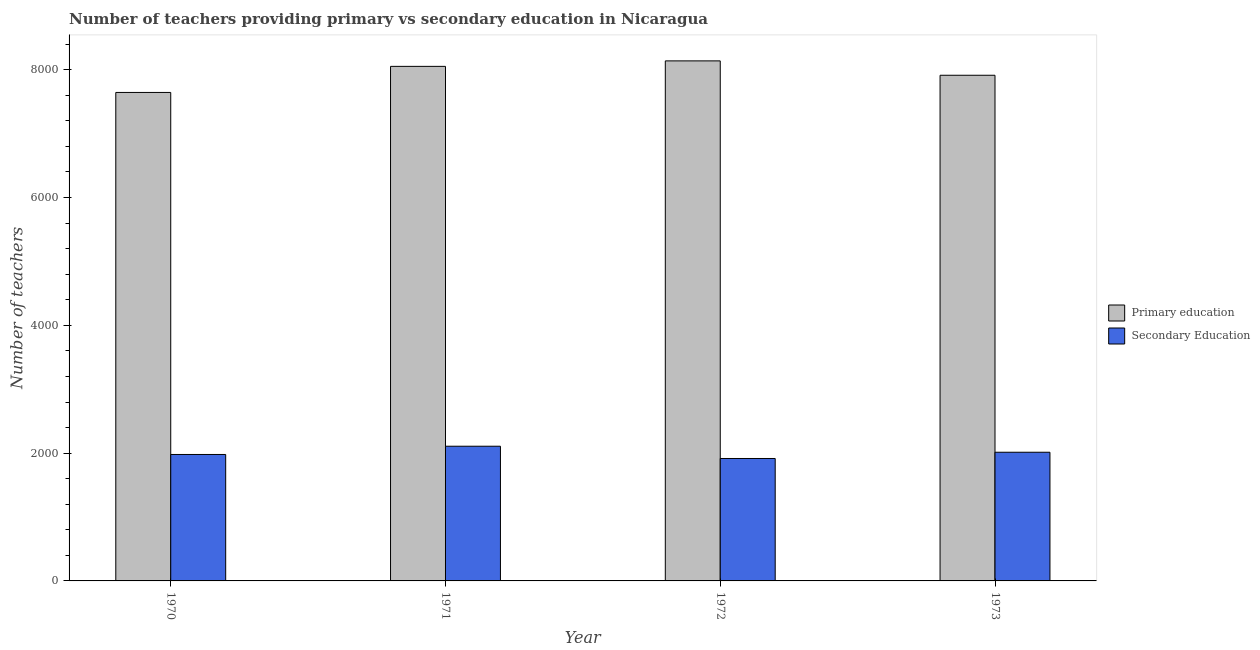How many different coloured bars are there?
Your answer should be compact. 2. How many bars are there on the 2nd tick from the left?
Offer a terse response. 2. In how many cases, is the number of bars for a given year not equal to the number of legend labels?
Offer a very short reply. 0. What is the number of primary teachers in 1972?
Offer a terse response. 8139. Across all years, what is the maximum number of primary teachers?
Ensure brevity in your answer.  8139. Across all years, what is the minimum number of primary teachers?
Provide a succinct answer. 7645. In which year was the number of primary teachers minimum?
Provide a succinct answer. 1970. What is the total number of primary teachers in the graph?
Keep it short and to the point. 3.18e+04. What is the difference between the number of primary teachers in 1970 and that in 1973?
Offer a terse response. -269. What is the difference between the number of secondary teachers in 1972 and the number of primary teachers in 1970?
Your answer should be compact. -63. What is the average number of primary teachers per year?
Your response must be concise. 7937.75. What is the ratio of the number of secondary teachers in 1972 to that in 1973?
Your answer should be compact. 0.95. What is the difference between the highest and the lowest number of secondary teachers?
Ensure brevity in your answer.  192. Is the sum of the number of primary teachers in 1972 and 1973 greater than the maximum number of secondary teachers across all years?
Give a very brief answer. Yes. What does the 2nd bar from the left in 1970 represents?
Your answer should be compact. Secondary Education. What does the 1st bar from the right in 1971 represents?
Your response must be concise. Secondary Education. How many bars are there?
Provide a succinct answer. 8. How many years are there in the graph?
Provide a succinct answer. 4. Are the values on the major ticks of Y-axis written in scientific E-notation?
Keep it short and to the point. No. Does the graph contain any zero values?
Your response must be concise. No. Does the graph contain grids?
Offer a very short reply. No. How many legend labels are there?
Make the answer very short. 2. How are the legend labels stacked?
Your response must be concise. Vertical. What is the title of the graph?
Keep it short and to the point. Number of teachers providing primary vs secondary education in Nicaragua. Does "Canada" appear as one of the legend labels in the graph?
Make the answer very short. No. What is the label or title of the X-axis?
Provide a short and direct response. Year. What is the label or title of the Y-axis?
Give a very brief answer. Number of teachers. What is the Number of teachers of Primary education in 1970?
Your response must be concise. 7645. What is the Number of teachers in Secondary Education in 1970?
Provide a succinct answer. 1979. What is the Number of teachers in Primary education in 1971?
Offer a terse response. 8053. What is the Number of teachers in Secondary Education in 1971?
Offer a terse response. 2108. What is the Number of teachers in Primary education in 1972?
Your response must be concise. 8139. What is the Number of teachers in Secondary Education in 1972?
Your answer should be very brief. 1916. What is the Number of teachers of Primary education in 1973?
Your answer should be very brief. 7914. What is the Number of teachers in Secondary Education in 1973?
Make the answer very short. 2014. Across all years, what is the maximum Number of teachers of Primary education?
Give a very brief answer. 8139. Across all years, what is the maximum Number of teachers of Secondary Education?
Provide a succinct answer. 2108. Across all years, what is the minimum Number of teachers of Primary education?
Keep it short and to the point. 7645. Across all years, what is the minimum Number of teachers of Secondary Education?
Your response must be concise. 1916. What is the total Number of teachers in Primary education in the graph?
Make the answer very short. 3.18e+04. What is the total Number of teachers in Secondary Education in the graph?
Provide a succinct answer. 8017. What is the difference between the Number of teachers of Primary education in 1970 and that in 1971?
Provide a short and direct response. -408. What is the difference between the Number of teachers in Secondary Education in 1970 and that in 1971?
Give a very brief answer. -129. What is the difference between the Number of teachers in Primary education in 1970 and that in 1972?
Offer a very short reply. -494. What is the difference between the Number of teachers in Secondary Education in 1970 and that in 1972?
Offer a terse response. 63. What is the difference between the Number of teachers in Primary education in 1970 and that in 1973?
Provide a short and direct response. -269. What is the difference between the Number of teachers of Secondary Education in 1970 and that in 1973?
Ensure brevity in your answer.  -35. What is the difference between the Number of teachers in Primary education in 1971 and that in 1972?
Offer a terse response. -86. What is the difference between the Number of teachers in Secondary Education in 1971 and that in 1972?
Provide a short and direct response. 192. What is the difference between the Number of teachers of Primary education in 1971 and that in 1973?
Provide a succinct answer. 139. What is the difference between the Number of teachers of Secondary Education in 1971 and that in 1973?
Give a very brief answer. 94. What is the difference between the Number of teachers of Primary education in 1972 and that in 1973?
Your response must be concise. 225. What is the difference between the Number of teachers in Secondary Education in 1972 and that in 1973?
Your response must be concise. -98. What is the difference between the Number of teachers of Primary education in 1970 and the Number of teachers of Secondary Education in 1971?
Your answer should be compact. 5537. What is the difference between the Number of teachers in Primary education in 1970 and the Number of teachers in Secondary Education in 1972?
Ensure brevity in your answer.  5729. What is the difference between the Number of teachers in Primary education in 1970 and the Number of teachers in Secondary Education in 1973?
Your answer should be compact. 5631. What is the difference between the Number of teachers of Primary education in 1971 and the Number of teachers of Secondary Education in 1972?
Your answer should be compact. 6137. What is the difference between the Number of teachers in Primary education in 1971 and the Number of teachers in Secondary Education in 1973?
Your response must be concise. 6039. What is the difference between the Number of teachers of Primary education in 1972 and the Number of teachers of Secondary Education in 1973?
Your answer should be compact. 6125. What is the average Number of teachers of Primary education per year?
Ensure brevity in your answer.  7937.75. What is the average Number of teachers in Secondary Education per year?
Your answer should be very brief. 2004.25. In the year 1970, what is the difference between the Number of teachers in Primary education and Number of teachers in Secondary Education?
Your response must be concise. 5666. In the year 1971, what is the difference between the Number of teachers of Primary education and Number of teachers of Secondary Education?
Your answer should be compact. 5945. In the year 1972, what is the difference between the Number of teachers of Primary education and Number of teachers of Secondary Education?
Offer a very short reply. 6223. In the year 1973, what is the difference between the Number of teachers of Primary education and Number of teachers of Secondary Education?
Ensure brevity in your answer.  5900. What is the ratio of the Number of teachers of Primary education in 1970 to that in 1971?
Offer a terse response. 0.95. What is the ratio of the Number of teachers in Secondary Education in 1970 to that in 1971?
Your response must be concise. 0.94. What is the ratio of the Number of teachers in Primary education in 1970 to that in 1972?
Make the answer very short. 0.94. What is the ratio of the Number of teachers of Secondary Education in 1970 to that in 1972?
Provide a succinct answer. 1.03. What is the ratio of the Number of teachers of Primary education in 1970 to that in 1973?
Your answer should be compact. 0.97. What is the ratio of the Number of teachers in Secondary Education in 1970 to that in 1973?
Offer a very short reply. 0.98. What is the ratio of the Number of teachers in Primary education in 1971 to that in 1972?
Provide a short and direct response. 0.99. What is the ratio of the Number of teachers of Secondary Education in 1971 to that in 1972?
Offer a terse response. 1.1. What is the ratio of the Number of teachers in Primary education in 1971 to that in 1973?
Make the answer very short. 1.02. What is the ratio of the Number of teachers of Secondary Education in 1971 to that in 1973?
Offer a very short reply. 1.05. What is the ratio of the Number of teachers in Primary education in 1972 to that in 1973?
Ensure brevity in your answer.  1.03. What is the ratio of the Number of teachers of Secondary Education in 1972 to that in 1973?
Provide a short and direct response. 0.95. What is the difference between the highest and the second highest Number of teachers in Primary education?
Offer a very short reply. 86. What is the difference between the highest and the second highest Number of teachers in Secondary Education?
Your answer should be very brief. 94. What is the difference between the highest and the lowest Number of teachers of Primary education?
Offer a very short reply. 494. What is the difference between the highest and the lowest Number of teachers of Secondary Education?
Your answer should be very brief. 192. 